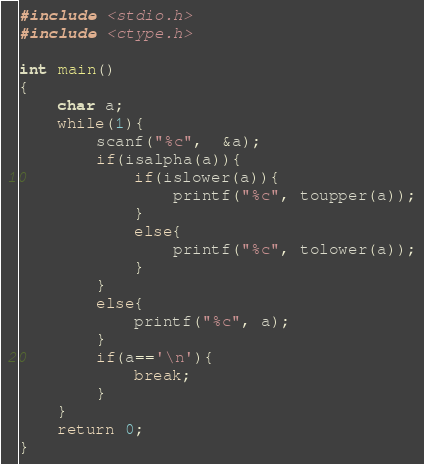Convert code to text. <code><loc_0><loc_0><loc_500><loc_500><_C_>#include <stdio.h>
#include <ctype.h>

int main()
{
	char a;
	while(1){
		scanf("%c",  &a);
		if(isalpha(a)){
			if(islower(a)){
				printf("%c", toupper(a));
			}
			else{
				printf("%c", tolower(a));
			}
		}
		else{
			printf("%c", a);
		}
		if(a=='\n'){
			break;
		}
	}
	return 0;
}</code> 